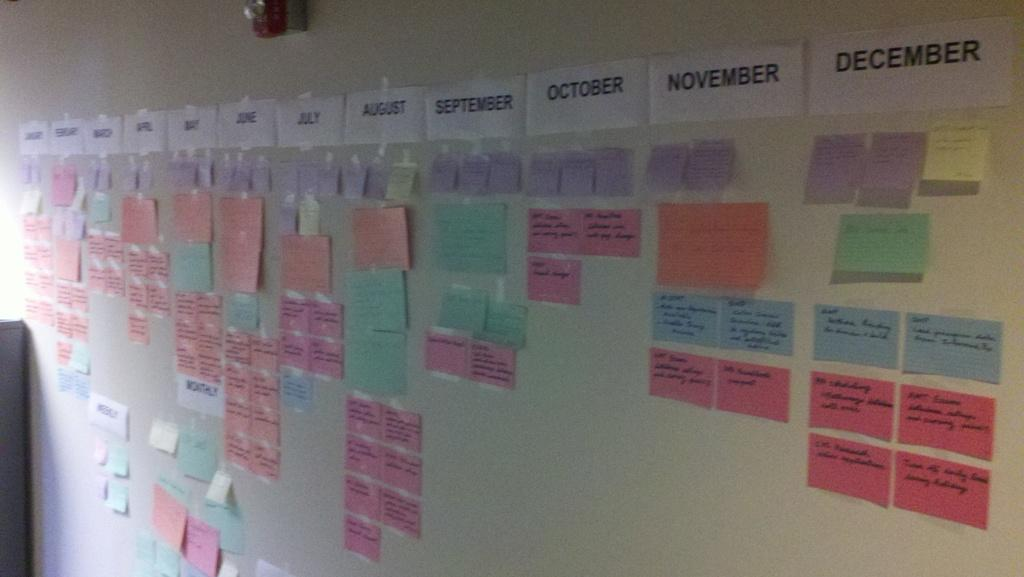<image>
Render a clear and concise summary of the photo. Many colorful notes are attached to a wall underneath the months of the year. 